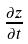Convert formula to latex. <formula><loc_0><loc_0><loc_500><loc_500>\frac { \partial z } { \partial t }</formula> 